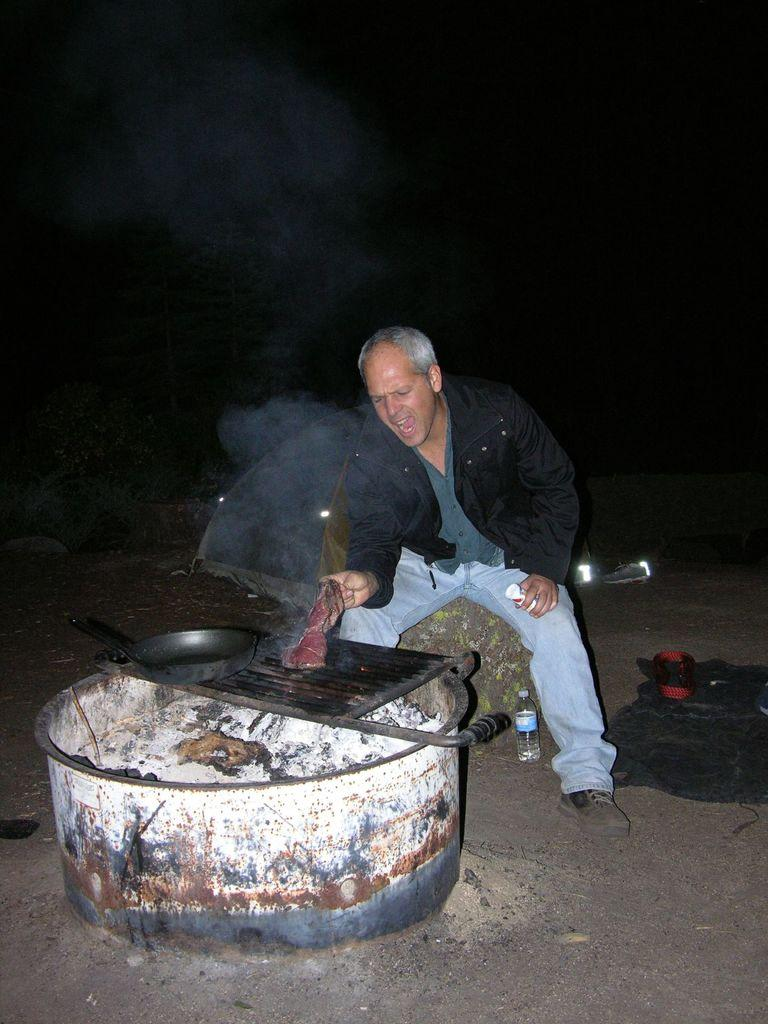What is the main subject of the image? There is a man standing in the middle of the image. What is the man holding in his hand? The man is holding something in his hand, but the specific object is not mentioned in the facts. What can be seen at the bottom of the image? There is a barbeque and a pan at the bottom of the image. Can you identify any other objects in the image? Yes, there is a water bottle in the image. How many lizards are crawling on the man's toes in the image? There are no lizards present in the image, and therefore no such activity can be observed. 